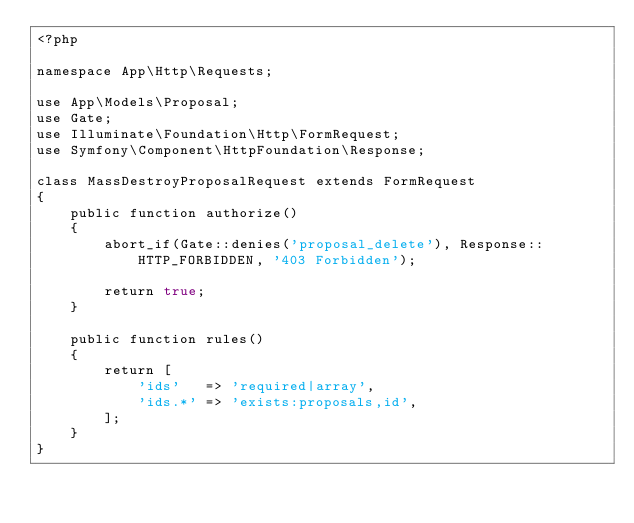Convert code to text. <code><loc_0><loc_0><loc_500><loc_500><_PHP_><?php

namespace App\Http\Requests;

use App\Models\Proposal;
use Gate;
use Illuminate\Foundation\Http\FormRequest;
use Symfony\Component\HttpFoundation\Response;

class MassDestroyProposalRequest extends FormRequest
{
    public function authorize()
    {
        abort_if(Gate::denies('proposal_delete'), Response::HTTP_FORBIDDEN, '403 Forbidden');

        return true;
    }

    public function rules()
    {
        return [
            'ids'   => 'required|array',
            'ids.*' => 'exists:proposals,id',
        ];
    }
}
</code> 